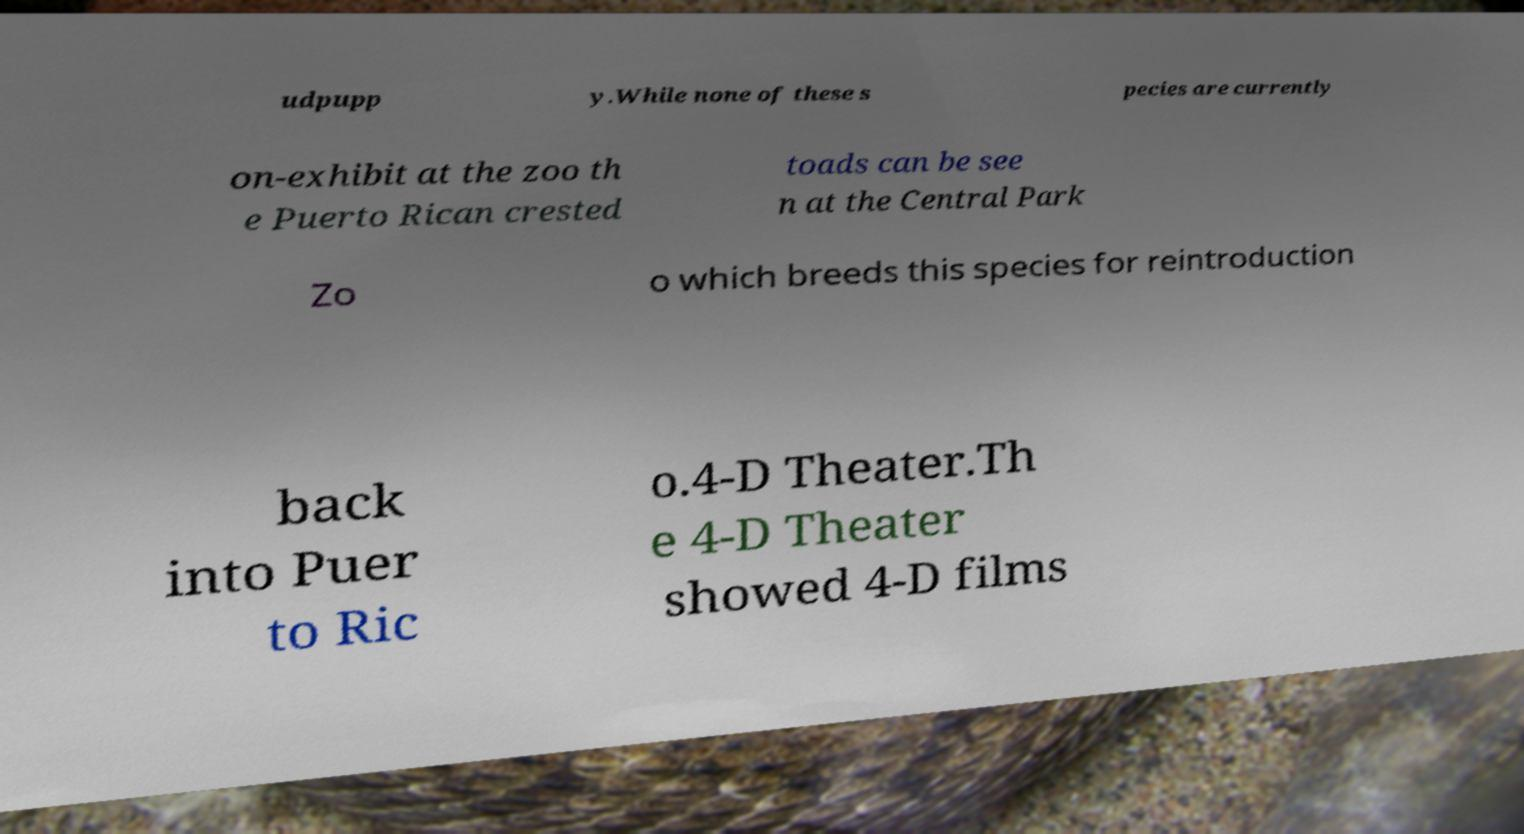Could you extract and type out the text from this image? udpupp y.While none of these s pecies are currently on-exhibit at the zoo th e Puerto Rican crested toads can be see n at the Central Park Zo o which breeds this species for reintroduction back into Puer to Ric o.4-D Theater.Th e 4-D Theater showed 4-D films 